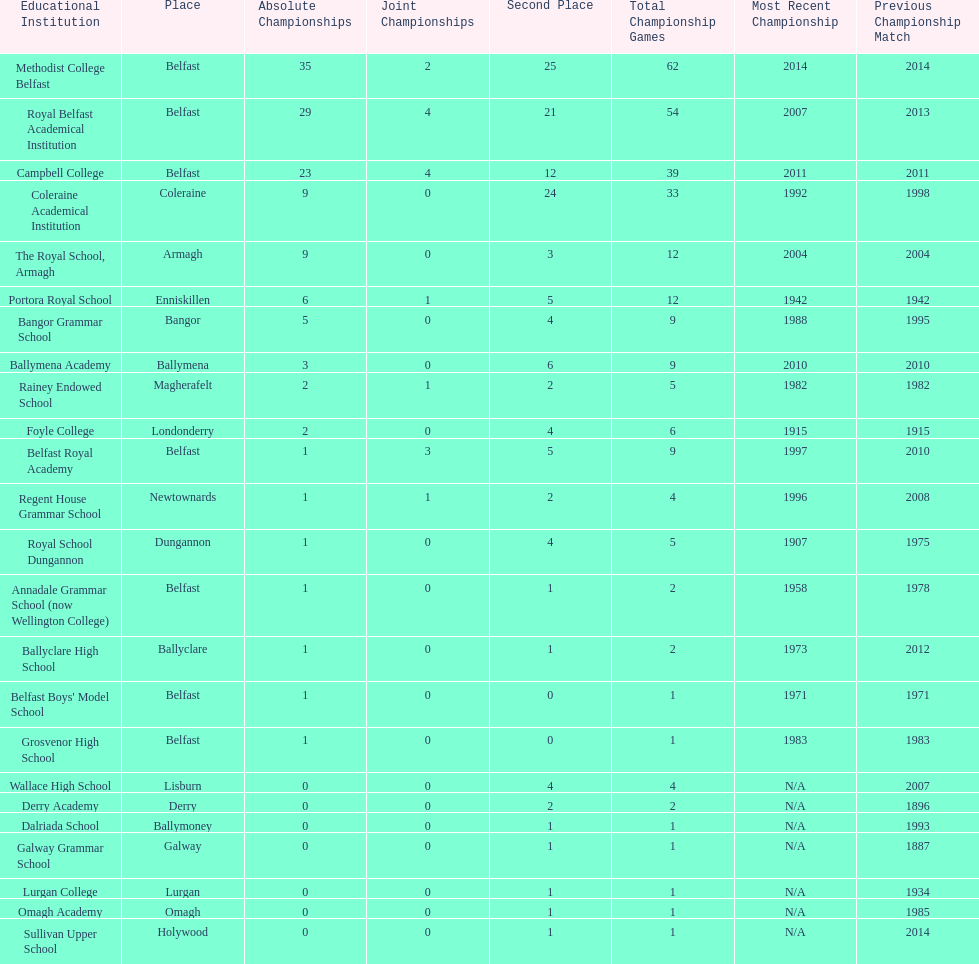Which two schools each had twelve total finals? The Royal School, Armagh, Portora Royal School. 